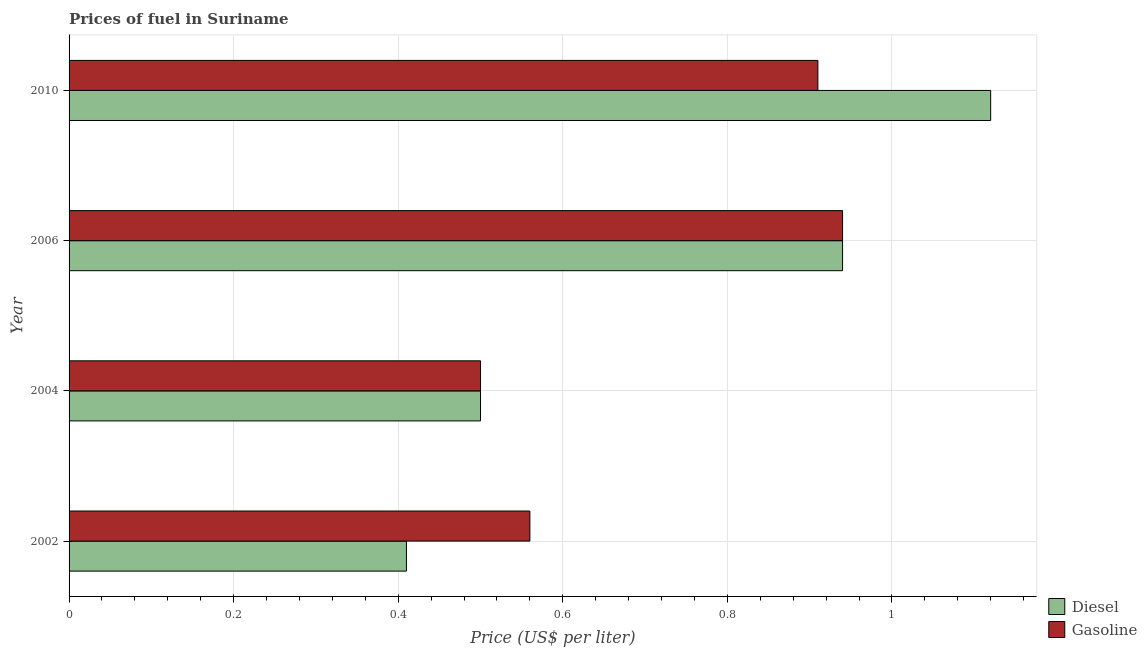How many different coloured bars are there?
Make the answer very short. 2. How many groups of bars are there?
Provide a succinct answer. 4. How many bars are there on the 2nd tick from the bottom?
Give a very brief answer. 2. In how many cases, is the number of bars for a given year not equal to the number of legend labels?
Your answer should be compact. 0. What is the diesel price in 2004?
Ensure brevity in your answer.  0.5. Across all years, what is the maximum diesel price?
Offer a terse response. 1.12. Across all years, what is the minimum gasoline price?
Provide a succinct answer. 0.5. In which year was the gasoline price minimum?
Your answer should be compact. 2004. What is the total diesel price in the graph?
Give a very brief answer. 2.97. What is the difference between the diesel price in 2002 and that in 2004?
Make the answer very short. -0.09. What is the difference between the diesel price in 2006 and the gasoline price in 2010?
Your answer should be compact. 0.03. What is the average gasoline price per year?
Your answer should be compact. 0.73. In how many years, is the diesel price greater than 0.7600000000000001 US$ per litre?
Ensure brevity in your answer.  2. What is the ratio of the diesel price in 2006 to that in 2010?
Keep it short and to the point. 0.84. Is the difference between the diesel price in 2002 and 2010 greater than the difference between the gasoline price in 2002 and 2010?
Provide a succinct answer. No. What is the difference between the highest and the second highest gasoline price?
Make the answer very short. 0.03. What is the difference between the highest and the lowest diesel price?
Your response must be concise. 0.71. In how many years, is the gasoline price greater than the average gasoline price taken over all years?
Give a very brief answer. 2. Is the sum of the diesel price in 2002 and 2010 greater than the maximum gasoline price across all years?
Provide a succinct answer. Yes. What does the 1st bar from the top in 2002 represents?
Ensure brevity in your answer.  Gasoline. What does the 1st bar from the bottom in 2010 represents?
Make the answer very short. Diesel. How many bars are there?
Keep it short and to the point. 8. Are the values on the major ticks of X-axis written in scientific E-notation?
Keep it short and to the point. No. Does the graph contain any zero values?
Your answer should be compact. No. Where does the legend appear in the graph?
Provide a succinct answer. Bottom right. What is the title of the graph?
Provide a short and direct response. Prices of fuel in Suriname. Does "From production" appear as one of the legend labels in the graph?
Your answer should be very brief. No. What is the label or title of the X-axis?
Your answer should be very brief. Price (US$ per liter). What is the label or title of the Y-axis?
Provide a succinct answer. Year. What is the Price (US$ per liter) of Diesel in 2002?
Provide a succinct answer. 0.41. What is the Price (US$ per liter) of Gasoline in 2002?
Give a very brief answer. 0.56. What is the Price (US$ per liter) in Diesel in 2004?
Your answer should be very brief. 0.5. What is the Price (US$ per liter) in Gasoline in 2004?
Your answer should be compact. 0.5. What is the Price (US$ per liter) in Diesel in 2006?
Keep it short and to the point. 0.94. What is the Price (US$ per liter) in Diesel in 2010?
Your answer should be compact. 1.12. What is the Price (US$ per liter) in Gasoline in 2010?
Your answer should be compact. 0.91. Across all years, what is the maximum Price (US$ per liter) in Diesel?
Offer a very short reply. 1.12. Across all years, what is the maximum Price (US$ per liter) of Gasoline?
Ensure brevity in your answer.  0.94. Across all years, what is the minimum Price (US$ per liter) in Diesel?
Give a very brief answer. 0.41. Across all years, what is the minimum Price (US$ per liter) in Gasoline?
Your response must be concise. 0.5. What is the total Price (US$ per liter) of Diesel in the graph?
Your response must be concise. 2.97. What is the total Price (US$ per liter) of Gasoline in the graph?
Provide a succinct answer. 2.91. What is the difference between the Price (US$ per liter) of Diesel in 2002 and that in 2004?
Your response must be concise. -0.09. What is the difference between the Price (US$ per liter) in Gasoline in 2002 and that in 2004?
Keep it short and to the point. 0.06. What is the difference between the Price (US$ per liter) of Diesel in 2002 and that in 2006?
Offer a terse response. -0.53. What is the difference between the Price (US$ per liter) of Gasoline in 2002 and that in 2006?
Your answer should be compact. -0.38. What is the difference between the Price (US$ per liter) of Diesel in 2002 and that in 2010?
Provide a succinct answer. -0.71. What is the difference between the Price (US$ per liter) of Gasoline in 2002 and that in 2010?
Your response must be concise. -0.35. What is the difference between the Price (US$ per liter) of Diesel in 2004 and that in 2006?
Your answer should be very brief. -0.44. What is the difference between the Price (US$ per liter) in Gasoline in 2004 and that in 2006?
Your response must be concise. -0.44. What is the difference between the Price (US$ per liter) in Diesel in 2004 and that in 2010?
Provide a short and direct response. -0.62. What is the difference between the Price (US$ per liter) in Gasoline in 2004 and that in 2010?
Offer a very short reply. -0.41. What is the difference between the Price (US$ per liter) of Diesel in 2006 and that in 2010?
Offer a terse response. -0.18. What is the difference between the Price (US$ per liter) of Gasoline in 2006 and that in 2010?
Your response must be concise. 0.03. What is the difference between the Price (US$ per liter) of Diesel in 2002 and the Price (US$ per liter) of Gasoline in 2004?
Provide a short and direct response. -0.09. What is the difference between the Price (US$ per liter) of Diesel in 2002 and the Price (US$ per liter) of Gasoline in 2006?
Ensure brevity in your answer.  -0.53. What is the difference between the Price (US$ per liter) in Diesel in 2002 and the Price (US$ per liter) in Gasoline in 2010?
Keep it short and to the point. -0.5. What is the difference between the Price (US$ per liter) of Diesel in 2004 and the Price (US$ per liter) of Gasoline in 2006?
Ensure brevity in your answer.  -0.44. What is the difference between the Price (US$ per liter) of Diesel in 2004 and the Price (US$ per liter) of Gasoline in 2010?
Offer a terse response. -0.41. What is the average Price (US$ per liter) of Diesel per year?
Give a very brief answer. 0.74. What is the average Price (US$ per liter) in Gasoline per year?
Provide a short and direct response. 0.73. In the year 2002, what is the difference between the Price (US$ per liter) in Diesel and Price (US$ per liter) in Gasoline?
Ensure brevity in your answer.  -0.15. In the year 2006, what is the difference between the Price (US$ per liter) in Diesel and Price (US$ per liter) in Gasoline?
Give a very brief answer. 0. In the year 2010, what is the difference between the Price (US$ per liter) in Diesel and Price (US$ per liter) in Gasoline?
Your response must be concise. 0.21. What is the ratio of the Price (US$ per liter) of Diesel in 2002 to that in 2004?
Keep it short and to the point. 0.82. What is the ratio of the Price (US$ per liter) in Gasoline in 2002 to that in 2004?
Your answer should be compact. 1.12. What is the ratio of the Price (US$ per liter) of Diesel in 2002 to that in 2006?
Provide a short and direct response. 0.44. What is the ratio of the Price (US$ per liter) in Gasoline in 2002 to that in 2006?
Provide a succinct answer. 0.6. What is the ratio of the Price (US$ per liter) of Diesel in 2002 to that in 2010?
Provide a short and direct response. 0.37. What is the ratio of the Price (US$ per liter) of Gasoline in 2002 to that in 2010?
Offer a very short reply. 0.62. What is the ratio of the Price (US$ per liter) of Diesel in 2004 to that in 2006?
Your answer should be very brief. 0.53. What is the ratio of the Price (US$ per liter) in Gasoline in 2004 to that in 2006?
Offer a very short reply. 0.53. What is the ratio of the Price (US$ per liter) of Diesel in 2004 to that in 2010?
Keep it short and to the point. 0.45. What is the ratio of the Price (US$ per liter) in Gasoline in 2004 to that in 2010?
Your response must be concise. 0.55. What is the ratio of the Price (US$ per liter) in Diesel in 2006 to that in 2010?
Make the answer very short. 0.84. What is the ratio of the Price (US$ per liter) in Gasoline in 2006 to that in 2010?
Offer a terse response. 1.03. What is the difference between the highest and the second highest Price (US$ per liter) of Diesel?
Provide a succinct answer. 0.18. What is the difference between the highest and the second highest Price (US$ per liter) of Gasoline?
Your response must be concise. 0.03. What is the difference between the highest and the lowest Price (US$ per liter) in Diesel?
Ensure brevity in your answer.  0.71. What is the difference between the highest and the lowest Price (US$ per liter) of Gasoline?
Offer a terse response. 0.44. 